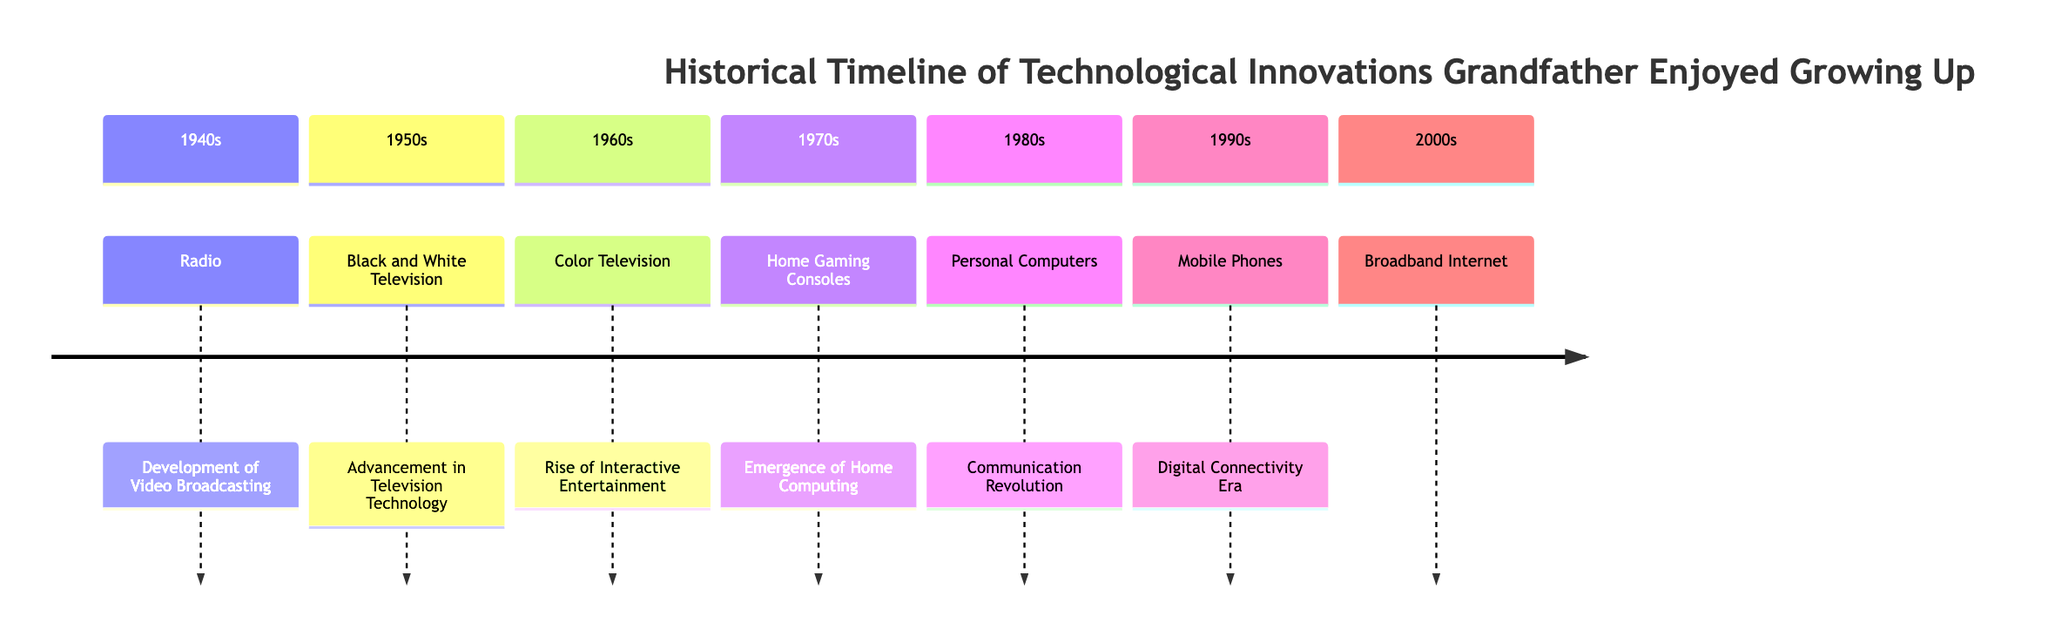What technological innovation appeared in the 1960s? According to the diagram, the innovation listed for the 1960s is Color Television.
Answer: Color Television How many sections are there in the diagram? The diagram has a total of seven sections, one for each decade from the 1940s to the 2000s.
Answer: 7 What decade saw the emergence of Home Gaming Consoles? The diagram indicates that Home Gaming Consoles appeared in the 1970s.
Answer: 1970s Which innovation corresponds to the 1980s? The innovation for the 1980s, as indicated in the diagram, is Personal Computers.
Answer: Personal Computers In which decade did Digital Connectivity Era innovations begin? The diagram shows that the Digital Connectivity Era began with Mobile Phones in the 1990s.
Answer: 1990s What relationship exists between Black and White Television and Color Television? The diagram suggests that Black and White Television was a predecessor to Color Television, marking an advancement in television technology.
Answer: Advancement Which section follows the 2000s in the timeline? The timeline does not extend past the 2000s, so there is no section that follows it.
Answer: None What was the first technological innovation listed in the diagram? The first technological innovation mentioned in the diagram is Radio, which is from the 1940s.
Answer: Radio Which two decades directly relate to home computing innovations? Home Gaming Consoles are from the 1970s and Personal Computers are from the 1980s, both relating to home computing.
Answer: 1970s, 1980s 